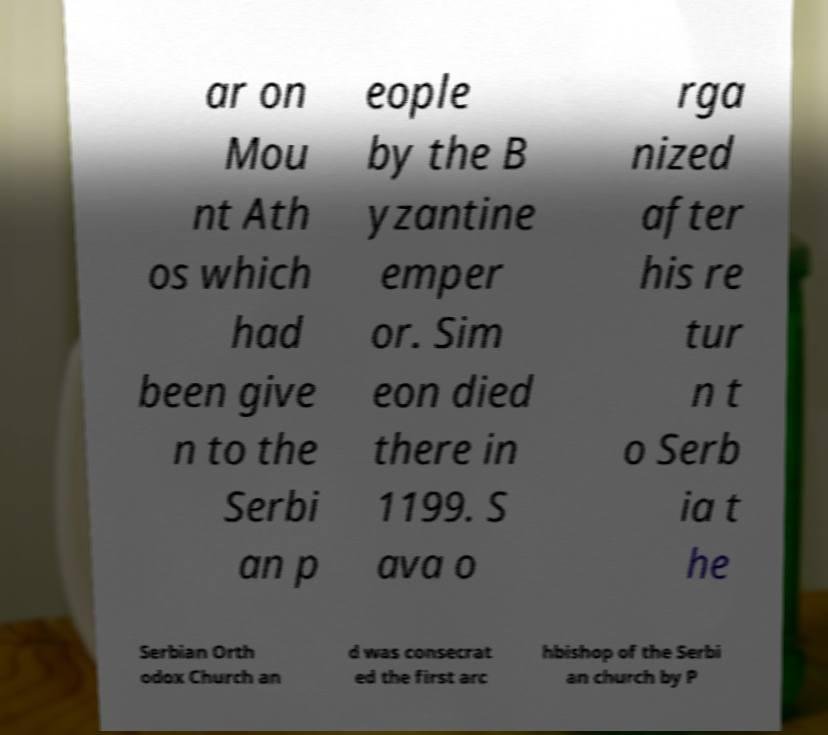Could you assist in decoding the text presented in this image and type it out clearly? ar on Mou nt Ath os which had been give n to the Serbi an p eople by the B yzantine emper or. Sim eon died there in 1199. S ava o rga nized after his re tur n t o Serb ia t he Serbian Orth odox Church an d was consecrat ed the first arc hbishop of the Serbi an church by P 